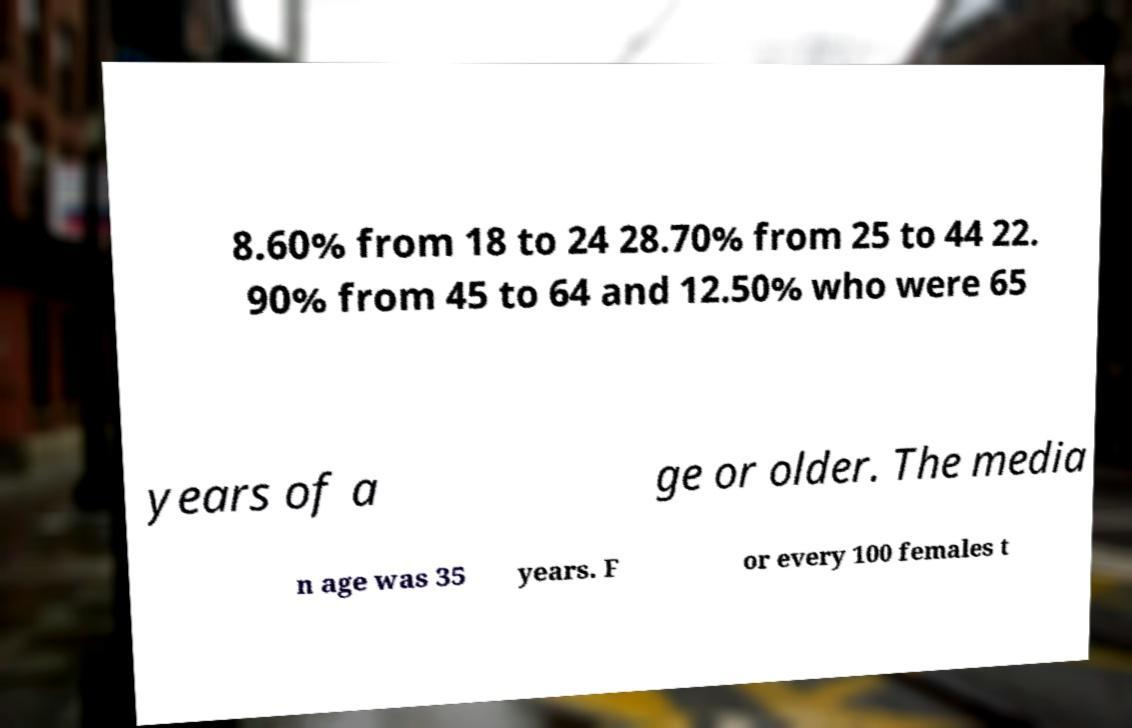Can you read and provide the text displayed in the image?This photo seems to have some interesting text. Can you extract and type it out for me? 8.60% from 18 to 24 28.70% from 25 to 44 22. 90% from 45 to 64 and 12.50% who were 65 years of a ge or older. The media n age was 35 years. F or every 100 females t 